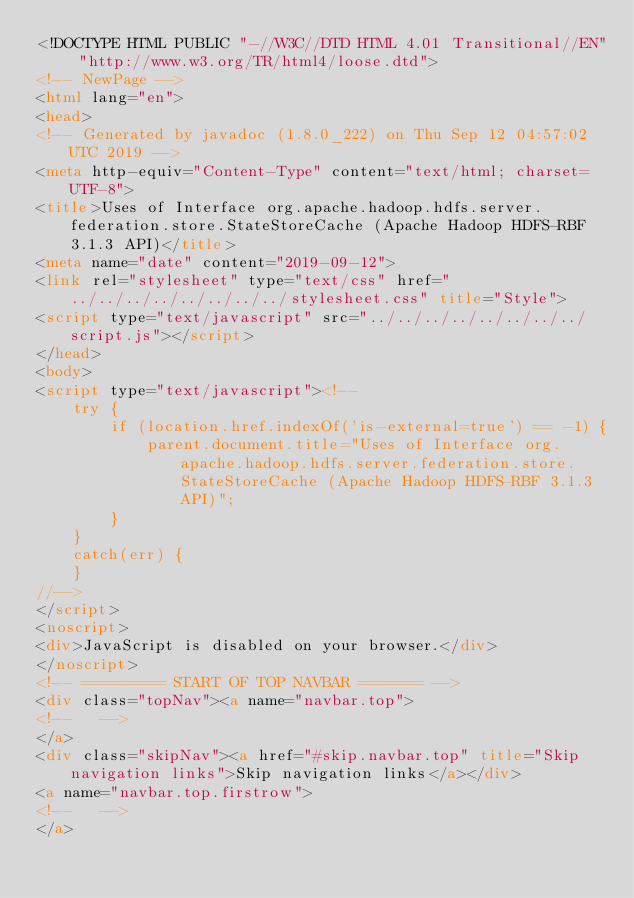<code> <loc_0><loc_0><loc_500><loc_500><_HTML_><!DOCTYPE HTML PUBLIC "-//W3C//DTD HTML 4.01 Transitional//EN" "http://www.w3.org/TR/html4/loose.dtd">
<!-- NewPage -->
<html lang="en">
<head>
<!-- Generated by javadoc (1.8.0_222) on Thu Sep 12 04:57:02 UTC 2019 -->
<meta http-equiv="Content-Type" content="text/html; charset=UTF-8">
<title>Uses of Interface org.apache.hadoop.hdfs.server.federation.store.StateStoreCache (Apache Hadoop HDFS-RBF 3.1.3 API)</title>
<meta name="date" content="2019-09-12">
<link rel="stylesheet" type="text/css" href="../../../../../../../../stylesheet.css" title="Style">
<script type="text/javascript" src="../../../../../../../../script.js"></script>
</head>
<body>
<script type="text/javascript"><!--
    try {
        if (location.href.indexOf('is-external=true') == -1) {
            parent.document.title="Uses of Interface org.apache.hadoop.hdfs.server.federation.store.StateStoreCache (Apache Hadoop HDFS-RBF 3.1.3 API)";
        }
    }
    catch(err) {
    }
//-->
</script>
<noscript>
<div>JavaScript is disabled on your browser.</div>
</noscript>
<!-- ========= START OF TOP NAVBAR ======= -->
<div class="topNav"><a name="navbar.top">
<!--   -->
</a>
<div class="skipNav"><a href="#skip.navbar.top" title="Skip navigation links">Skip navigation links</a></div>
<a name="navbar.top.firstrow">
<!--   -->
</a></code> 